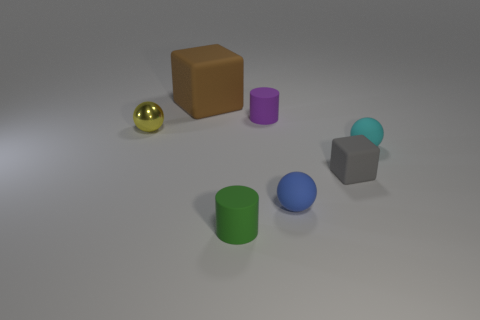Add 1 purple cylinders. How many objects exist? 8 Subtract all cubes. How many objects are left? 5 Subtract all small blue rubber spheres. Subtract all big brown things. How many objects are left? 5 Add 3 tiny purple things. How many tiny purple things are left? 4 Add 3 tiny rubber balls. How many tiny rubber balls exist? 5 Subtract 1 purple cylinders. How many objects are left? 6 